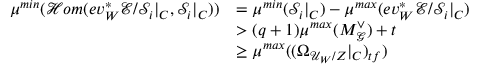Convert formula to latex. <formula><loc_0><loc_0><loc_500><loc_500>\begin{array} { r l } { \mu ^ { \min } ( \mathcal { H } o m ( e v _ { W } ^ { * } \mathcal { E } / \mathcal { S } _ { i } | _ { C } , \mathcal { S } _ { i } | _ { C } ) ) } & { = \mu ^ { \min } ( \mathcal { S } _ { i } | _ { C } ) - \mu ^ { \max } ( e v _ { W } ^ { * } \mathcal { E } / \mathcal { S } _ { i } | _ { C } ) } \\ & { > ( q + 1 ) \mu ^ { \max } ( M _ { \mathcal { G } } ^ { \vee } ) + t } \\ & { \geq \mu ^ { \max } ( ( \Omega _ { \mathcal { U } _ { W } / Z } | _ { C } ) _ { t f } ) } \end{array}</formula> 